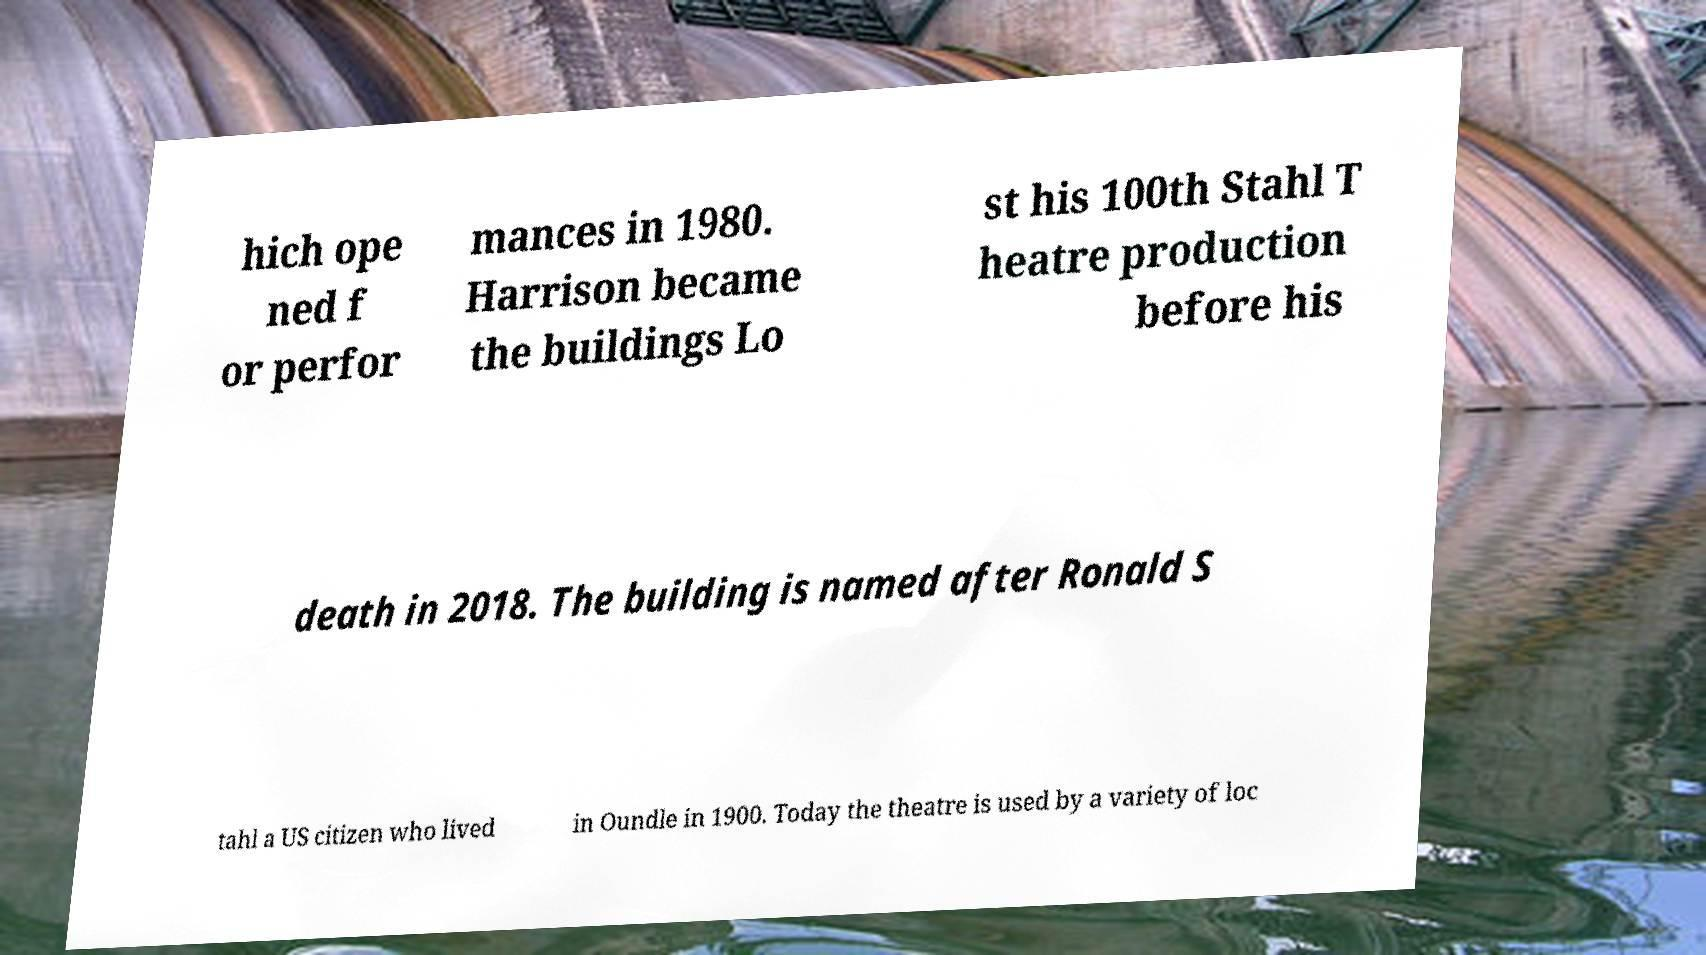Could you assist in decoding the text presented in this image and type it out clearly? hich ope ned f or perfor mances in 1980. Harrison became the buildings Lo st his 100th Stahl T heatre production before his death in 2018. The building is named after Ronald S tahl a US citizen who lived in Oundle in 1900. Today the theatre is used by a variety of loc 